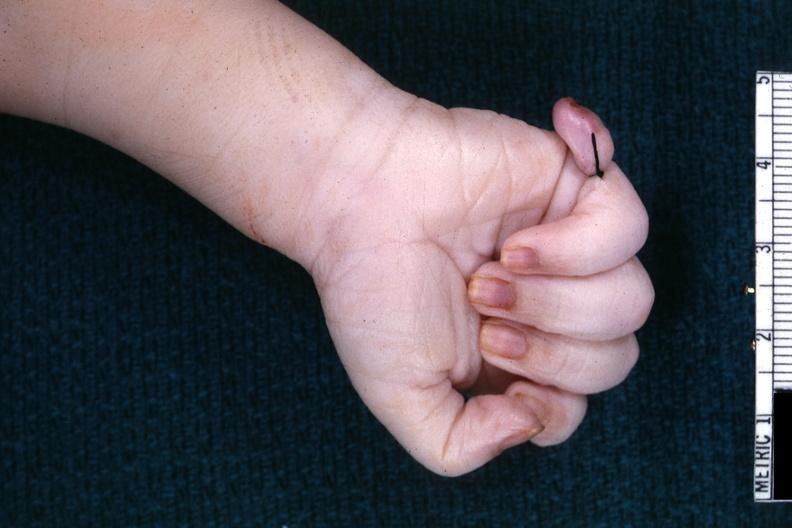what does this image show?
Answer the question using a single word or phrase. Good shot of sixth finger with ligature on it 